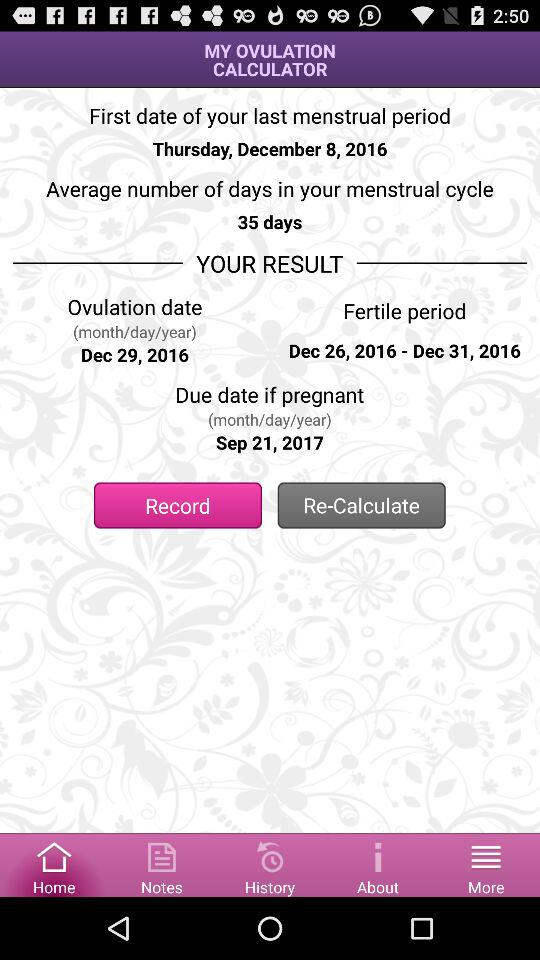What is the average number of days? The average number of days is 35. 